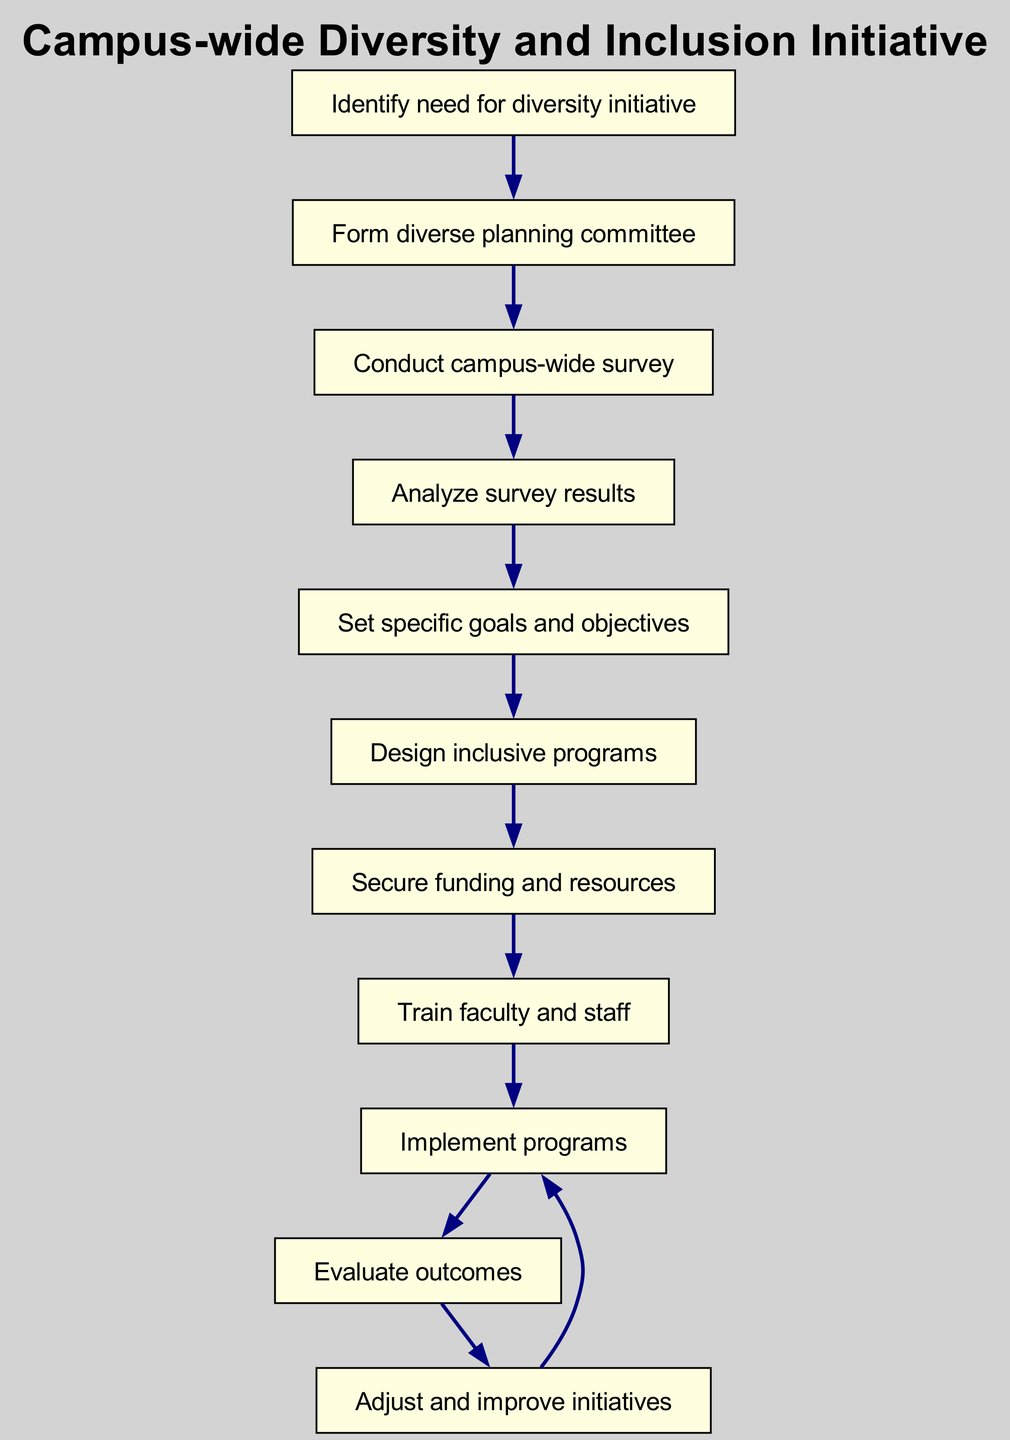What is the starting point of the initiative? The diagram identifies "Identify need for diversity initiative" as the starting point. This is indicated clearly at the top of the flow chart as the first node to begin the process.
Answer: Identify need for diversity initiative How many nodes are present in the diagram? To determine the total number of nodes, we count each individual step or stage represented in the flow chart, which includes the starting node and all subsequent steps. The count totals 10.
Answer: 10 Which node follows "Secure funding and resources"? The flow chart shows a directional edge leading from "Secure funding and resources" to "Train faculty and staff", indicating the next step after securing resources is training faculty and staff.
Answer: Train faculty and staff What is the last step in the initiative? From the flow chart, the evaluation of outcomes leads to "Adjust and improve initiatives", after which the flow shows it can loop back to "Implement programs", but the last distinct step is "Adjust and improve initiatives".
Answer: Adjust and improve initiatives Which node is directly connected to "Implement programs"? The diagram indicates that "Evaluate outcomes" is the node that directly precedes "Implement programs", implying that evaluation must occur before implementation.
Answer: Evaluate outcomes How many edges are in the diagram? By counting each link between nodes, we can determine the number of edges present in the flow chart. The total count gives us 10 edges.
Answer: 10 What comes after "Analyze survey results"? The flow chart shows that "Set specific goals and objectives" comes directly after "Analyze survey results", following the logical order of the initiative's steps.
Answer: Set specific goals and objectives Which two nodes are connected by an edge from "Train faculty and staff"? According to the diagram, the edge from "Train faculty and staff" leads to "Implement programs", indicating the immediate action that follows training.
Answer: Implement programs What is the purpose of the "Conduct campus-wide survey" node? The purpose of this node is to gather essential data that informs the planning and implementation of diversity initiatives, providing necessary insights into the needs of the campus community.
Answer: Gather data 